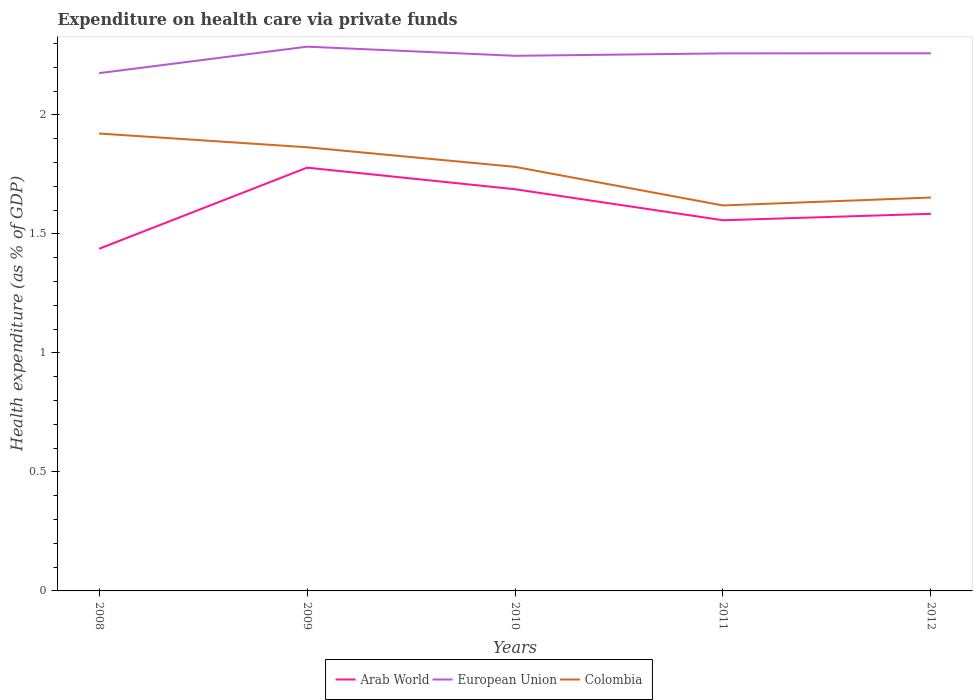Is the number of lines equal to the number of legend labels?
Offer a very short reply. Yes. Across all years, what is the maximum expenditure made on health care in Colombia?
Ensure brevity in your answer.  1.62. In which year was the expenditure made on health care in Arab World maximum?
Give a very brief answer. 2008. What is the total expenditure made on health care in European Union in the graph?
Provide a succinct answer. -0.08. What is the difference between the highest and the second highest expenditure made on health care in Arab World?
Offer a terse response. 0.34. Is the expenditure made on health care in European Union strictly greater than the expenditure made on health care in Colombia over the years?
Provide a short and direct response. No. How many lines are there?
Your answer should be very brief. 3. Does the graph contain grids?
Your response must be concise. No. How many legend labels are there?
Your answer should be very brief. 3. How are the legend labels stacked?
Offer a very short reply. Horizontal. What is the title of the graph?
Make the answer very short. Expenditure on health care via private funds. Does "Malaysia" appear as one of the legend labels in the graph?
Your answer should be compact. No. What is the label or title of the Y-axis?
Your response must be concise. Health expenditure (as % of GDP). What is the Health expenditure (as % of GDP) in Arab World in 2008?
Provide a short and direct response. 1.44. What is the Health expenditure (as % of GDP) in European Union in 2008?
Offer a very short reply. 2.18. What is the Health expenditure (as % of GDP) in Colombia in 2008?
Offer a very short reply. 1.92. What is the Health expenditure (as % of GDP) in Arab World in 2009?
Your answer should be compact. 1.78. What is the Health expenditure (as % of GDP) in European Union in 2009?
Provide a short and direct response. 2.29. What is the Health expenditure (as % of GDP) of Colombia in 2009?
Your answer should be compact. 1.86. What is the Health expenditure (as % of GDP) in Arab World in 2010?
Keep it short and to the point. 1.69. What is the Health expenditure (as % of GDP) of European Union in 2010?
Offer a very short reply. 2.25. What is the Health expenditure (as % of GDP) of Colombia in 2010?
Make the answer very short. 1.78. What is the Health expenditure (as % of GDP) of Arab World in 2011?
Give a very brief answer. 1.56. What is the Health expenditure (as % of GDP) of European Union in 2011?
Your answer should be compact. 2.26. What is the Health expenditure (as % of GDP) in Colombia in 2011?
Make the answer very short. 1.62. What is the Health expenditure (as % of GDP) in Arab World in 2012?
Your answer should be very brief. 1.58. What is the Health expenditure (as % of GDP) of European Union in 2012?
Your answer should be very brief. 2.26. What is the Health expenditure (as % of GDP) of Colombia in 2012?
Offer a terse response. 1.65. Across all years, what is the maximum Health expenditure (as % of GDP) of Arab World?
Your answer should be very brief. 1.78. Across all years, what is the maximum Health expenditure (as % of GDP) in European Union?
Make the answer very short. 2.29. Across all years, what is the maximum Health expenditure (as % of GDP) in Colombia?
Offer a very short reply. 1.92. Across all years, what is the minimum Health expenditure (as % of GDP) of Arab World?
Give a very brief answer. 1.44. Across all years, what is the minimum Health expenditure (as % of GDP) of European Union?
Keep it short and to the point. 2.18. Across all years, what is the minimum Health expenditure (as % of GDP) of Colombia?
Your answer should be compact. 1.62. What is the total Health expenditure (as % of GDP) in Arab World in the graph?
Provide a succinct answer. 8.05. What is the total Health expenditure (as % of GDP) of European Union in the graph?
Make the answer very short. 11.23. What is the total Health expenditure (as % of GDP) of Colombia in the graph?
Give a very brief answer. 8.84. What is the difference between the Health expenditure (as % of GDP) of Arab World in 2008 and that in 2009?
Your answer should be compact. -0.34. What is the difference between the Health expenditure (as % of GDP) in European Union in 2008 and that in 2009?
Offer a terse response. -0.11. What is the difference between the Health expenditure (as % of GDP) in Colombia in 2008 and that in 2009?
Your answer should be very brief. 0.06. What is the difference between the Health expenditure (as % of GDP) in Arab World in 2008 and that in 2010?
Your answer should be very brief. -0.25. What is the difference between the Health expenditure (as % of GDP) in European Union in 2008 and that in 2010?
Provide a succinct answer. -0.07. What is the difference between the Health expenditure (as % of GDP) in Colombia in 2008 and that in 2010?
Make the answer very short. 0.14. What is the difference between the Health expenditure (as % of GDP) of Arab World in 2008 and that in 2011?
Ensure brevity in your answer.  -0.12. What is the difference between the Health expenditure (as % of GDP) of European Union in 2008 and that in 2011?
Offer a very short reply. -0.08. What is the difference between the Health expenditure (as % of GDP) of Colombia in 2008 and that in 2011?
Keep it short and to the point. 0.3. What is the difference between the Health expenditure (as % of GDP) of Arab World in 2008 and that in 2012?
Ensure brevity in your answer.  -0.15. What is the difference between the Health expenditure (as % of GDP) of European Union in 2008 and that in 2012?
Your response must be concise. -0.08. What is the difference between the Health expenditure (as % of GDP) of Colombia in 2008 and that in 2012?
Your answer should be very brief. 0.27. What is the difference between the Health expenditure (as % of GDP) in Arab World in 2009 and that in 2010?
Keep it short and to the point. 0.09. What is the difference between the Health expenditure (as % of GDP) of European Union in 2009 and that in 2010?
Provide a short and direct response. 0.04. What is the difference between the Health expenditure (as % of GDP) of Colombia in 2009 and that in 2010?
Offer a very short reply. 0.08. What is the difference between the Health expenditure (as % of GDP) in Arab World in 2009 and that in 2011?
Your answer should be very brief. 0.22. What is the difference between the Health expenditure (as % of GDP) in European Union in 2009 and that in 2011?
Give a very brief answer. 0.03. What is the difference between the Health expenditure (as % of GDP) in Colombia in 2009 and that in 2011?
Your response must be concise. 0.24. What is the difference between the Health expenditure (as % of GDP) of Arab World in 2009 and that in 2012?
Ensure brevity in your answer.  0.19. What is the difference between the Health expenditure (as % of GDP) in European Union in 2009 and that in 2012?
Provide a succinct answer. 0.03. What is the difference between the Health expenditure (as % of GDP) in Colombia in 2009 and that in 2012?
Provide a succinct answer. 0.21. What is the difference between the Health expenditure (as % of GDP) in Arab World in 2010 and that in 2011?
Ensure brevity in your answer.  0.13. What is the difference between the Health expenditure (as % of GDP) of European Union in 2010 and that in 2011?
Give a very brief answer. -0.01. What is the difference between the Health expenditure (as % of GDP) in Colombia in 2010 and that in 2011?
Your answer should be compact. 0.16. What is the difference between the Health expenditure (as % of GDP) in Arab World in 2010 and that in 2012?
Your answer should be very brief. 0.1. What is the difference between the Health expenditure (as % of GDP) of European Union in 2010 and that in 2012?
Your answer should be compact. -0.01. What is the difference between the Health expenditure (as % of GDP) of Colombia in 2010 and that in 2012?
Your answer should be very brief. 0.13. What is the difference between the Health expenditure (as % of GDP) of Arab World in 2011 and that in 2012?
Give a very brief answer. -0.03. What is the difference between the Health expenditure (as % of GDP) in European Union in 2011 and that in 2012?
Provide a short and direct response. -0. What is the difference between the Health expenditure (as % of GDP) in Colombia in 2011 and that in 2012?
Provide a succinct answer. -0.03. What is the difference between the Health expenditure (as % of GDP) of Arab World in 2008 and the Health expenditure (as % of GDP) of European Union in 2009?
Provide a succinct answer. -0.85. What is the difference between the Health expenditure (as % of GDP) of Arab World in 2008 and the Health expenditure (as % of GDP) of Colombia in 2009?
Make the answer very short. -0.43. What is the difference between the Health expenditure (as % of GDP) in European Union in 2008 and the Health expenditure (as % of GDP) in Colombia in 2009?
Provide a succinct answer. 0.31. What is the difference between the Health expenditure (as % of GDP) in Arab World in 2008 and the Health expenditure (as % of GDP) in European Union in 2010?
Make the answer very short. -0.81. What is the difference between the Health expenditure (as % of GDP) of Arab World in 2008 and the Health expenditure (as % of GDP) of Colombia in 2010?
Offer a very short reply. -0.34. What is the difference between the Health expenditure (as % of GDP) of European Union in 2008 and the Health expenditure (as % of GDP) of Colombia in 2010?
Your answer should be compact. 0.39. What is the difference between the Health expenditure (as % of GDP) in Arab World in 2008 and the Health expenditure (as % of GDP) in European Union in 2011?
Provide a succinct answer. -0.82. What is the difference between the Health expenditure (as % of GDP) in Arab World in 2008 and the Health expenditure (as % of GDP) in Colombia in 2011?
Your answer should be compact. -0.18. What is the difference between the Health expenditure (as % of GDP) in European Union in 2008 and the Health expenditure (as % of GDP) in Colombia in 2011?
Your response must be concise. 0.56. What is the difference between the Health expenditure (as % of GDP) of Arab World in 2008 and the Health expenditure (as % of GDP) of European Union in 2012?
Your answer should be very brief. -0.82. What is the difference between the Health expenditure (as % of GDP) of Arab World in 2008 and the Health expenditure (as % of GDP) of Colombia in 2012?
Provide a succinct answer. -0.22. What is the difference between the Health expenditure (as % of GDP) of European Union in 2008 and the Health expenditure (as % of GDP) of Colombia in 2012?
Make the answer very short. 0.52. What is the difference between the Health expenditure (as % of GDP) in Arab World in 2009 and the Health expenditure (as % of GDP) in European Union in 2010?
Make the answer very short. -0.47. What is the difference between the Health expenditure (as % of GDP) in Arab World in 2009 and the Health expenditure (as % of GDP) in Colombia in 2010?
Provide a succinct answer. -0. What is the difference between the Health expenditure (as % of GDP) in European Union in 2009 and the Health expenditure (as % of GDP) in Colombia in 2010?
Your response must be concise. 0.5. What is the difference between the Health expenditure (as % of GDP) in Arab World in 2009 and the Health expenditure (as % of GDP) in European Union in 2011?
Make the answer very short. -0.48. What is the difference between the Health expenditure (as % of GDP) in Arab World in 2009 and the Health expenditure (as % of GDP) in Colombia in 2011?
Give a very brief answer. 0.16. What is the difference between the Health expenditure (as % of GDP) in European Union in 2009 and the Health expenditure (as % of GDP) in Colombia in 2011?
Offer a very short reply. 0.67. What is the difference between the Health expenditure (as % of GDP) of Arab World in 2009 and the Health expenditure (as % of GDP) of European Union in 2012?
Provide a succinct answer. -0.48. What is the difference between the Health expenditure (as % of GDP) in Arab World in 2009 and the Health expenditure (as % of GDP) in Colombia in 2012?
Your response must be concise. 0.13. What is the difference between the Health expenditure (as % of GDP) in European Union in 2009 and the Health expenditure (as % of GDP) in Colombia in 2012?
Keep it short and to the point. 0.63. What is the difference between the Health expenditure (as % of GDP) in Arab World in 2010 and the Health expenditure (as % of GDP) in European Union in 2011?
Keep it short and to the point. -0.57. What is the difference between the Health expenditure (as % of GDP) in Arab World in 2010 and the Health expenditure (as % of GDP) in Colombia in 2011?
Make the answer very short. 0.07. What is the difference between the Health expenditure (as % of GDP) of European Union in 2010 and the Health expenditure (as % of GDP) of Colombia in 2011?
Your answer should be very brief. 0.63. What is the difference between the Health expenditure (as % of GDP) in Arab World in 2010 and the Health expenditure (as % of GDP) in European Union in 2012?
Your response must be concise. -0.57. What is the difference between the Health expenditure (as % of GDP) of Arab World in 2010 and the Health expenditure (as % of GDP) of Colombia in 2012?
Your answer should be compact. 0.03. What is the difference between the Health expenditure (as % of GDP) of European Union in 2010 and the Health expenditure (as % of GDP) of Colombia in 2012?
Make the answer very short. 0.6. What is the difference between the Health expenditure (as % of GDP) in Arab World in 2011 and the Health expenditure (as % of GDP) in European Union in 2012?
Your answer should be compact. -0.7. What is the difference between the Health expenditure (as % of GDP) of Arab World in 2011 and the Health expenditure (as % of GDP) of Colombia in 2012?
Your answer should be compact. -0.1. What is the difference between the Health expenditure (as % of GDP) of European Union in 2011 and the Health expenditure (as % of GDP) of Colombia in 2012?
Your response must be concise. 0.61. What is the average Health expenditure (as % of GDP) of Arab World per year?
Provide a succinct answer. 1.61. What is the average Health expenditure (as % of GDP) of European Union per year?
Your answer should be very brief. 2.25. What is the average Health expenditure (as % of GDP) in Colombia per year?
Give a very brief answer. 1.77. In the year 2008, what is the difference between the Health expenditure (as % of GDP) in Arab World and Health expenditure (as % of GDP) in European Union?
Provide a short and direct response. -0.74. In the year 2008, what is the difference between the Health expenditure (as % of GDP) of Arab World and Health expenditure (as % of GDP) of Colombia?
Your response must be concise. -0.48. In the year 2008, what is the difference between the Health expenditure (as % of GDP) of European Union and Health expenditure (as % of GDP) of Colombia?
Your answer should be compact. 0.25. In the year 2009, what is the difference between the Health expenditure (as % of GDP) of Arab World and Health expenditure (as % of GDP) of European Union?
Make the answer very short. -0.51. In the year 2009, what is the difference between the Health expenditure (as % of GDP) in Arab World and Health expenditure (as % of GDP) in Colombia?
Offer a terse response. -0.09. In the year 2009, what is the difference between the Health expenditure (as % of GDP) of European Union and Health expenditure (as % of GDP) of Colombia?
Offer a very short reply. 0.42. In the year 2010, what is the difference between the Health expenditure (as % of GDP) of Arab World and Health expenditure (as % of GDP) of European Union?
Your answer should be very brief. -0.56. In the year 2010, what is the difference between the Health expenditure (as % of GDP) of Arab World and Health expenditure (as % of GDP) of Colombia?
Offer a very short reply. -0.09. In the year 2010, what is the difference between the Health expenditure (as % of GDP) in European Union and Health expenditure (as % of GDP) in Colombia?
Offer a very short reply. 0.47. In the year 2011, what is the difference between the Health expenditure (as % of GDP) of Arab World and Health expenditure (as % of GDP) of European Union?
Your answer should be compact. -0.7. In the year 2011, what is the difference between the Health expenditure (as % of GDP) of Arab World and Health expenditure (as % of GDP) of Colombia?
Offer a very short reply. -0.06. In the year 2011, what is the difference between the Health expenditure (as % of GDP) of European Union and Health expenditure (as % of GDP) of Colombia?
Your answer should be compact. 0.64. In the year 2012, what is the difference between the Health expenditure (as % of GDP) in Arab World and Health expenditure (as % of GDP) in European Union?
Your response must be concise. -0.67. In the year 2012, what is the difference between the Health expenditure (as % of GDP) of Arab World and Health expenditure (as % of GDP) of Colombia?
Your response must be concise. -0.07. In the year 2012, what is the difference between the Health expenditure (as % of GDP) of European Union and Health expenditure (as % of GDP) of Colombia?
Keep it short and to the point. 0.61. What is the ratio of the Health expenditure (as % of GDP) in Arab World in 2008 to that in 2009?
Keep it short and to the point. 0.81. What is the ratio of the Health expenditure (as % of GDP) in European Union in 2008 to that in 2009?
Provide a short and direct response. 0.95. What is the ratio of the Health expenditure (as % of GDP) in Colombia in 2008 to that in 2009?
Provide a short and direct response. 1.03. What is the ratio of the Health expenditure (as % of GDP) of Arab World in 2008 to that in 2010?
Provide a succinct answer. 0.85. What is the ratio of the Health expenditure (as % of GDP) in European Union in 2008 to that in 2010?
Your answer should be very brief. 0.97. What is the ratio of the Health expenditure (as % of GDP) of Colombia in 2008 to that in 2010?
Keep it short and to the point. 1.08. What is the ratio of the Health expenditure (as % of GDP) in Arab World in 2008 to that in 2011?
Offer a very short reply. 0.92. What is the ratio of the Health expenditure (as % of GDP) of European Union in 2008 to that in 2011?
Keep it short and to the point. 0.96. What is the ratio of the Health expenditure (as % of GDP) of Colombia in 2008 to that in 2011?
Ensure brevity in your answer.  1.19. What is the ratio of the Health expenditure (as % of GDP) in Arab World in 2008 to that in 2012?
Make the answer very short. 0.91. What is the ratio of the Health expenditure (as % of GDP) of European Union in 2008 to that in 2012?
Your answer should be very brief. 0.96. What is the ratio of the Health expenditure (as % of GDP) of Colombia in 2008 to that in 2012?
Offer a very short reply. 1.16. What is the ratio of the Health expenditure (as % of GDP) in Arab World in 2009 to that in 2010?
Ensure brevity in your answer.  1.05. What is the ratio of the Health expenditure (as % of GDP) of European Union in 2009 to that in 2010?
Your answer should be very brief. 1.02. What is the ratio of the Health expenditure (as % of GDP) in Colombia in 2009 to that in 2010?
Provide a succinct answer. 1.05. What is the ratio of the Health expenditure (as % of GDP) in Arab World in 2009 to that in 2011?
Offer a terse response. 1.14. What is the ratio of the Health expenditure (as % of GDP) of European Union in 2009 to that in 2011?
Provide a succinct answer. 1.01. What is the ratio of the Health expenditure (as % of GDP) of Colombia in 2009 to that in 2011?
Your answer should be very brief. 1.15. What is the ratio of the Health expenditure (as % of GDP) of Arab World in 2009 to that in 2012?
Offer a terse response. 1.12. What is the ratio of the Health expenditure (as % of GDP) of European Union in 2009 to that in 2012?
Your answer should be compact. 1.01. What is the ratio of the Health expenditure (as % of GDP) in Colombia in 2009 to that in 2012?
Your response must be concise. 1.13. What is the ratio of the Health expenditure (as % of GDP) of Arab World in 2010 to that in 2011?
Keep it short and to the point. 1.08. What is the ratio of the Health expenditure (as % of GDP) in European Union in 2010 to that in 2011?
Offer a very short reply. 1. What is the ratio of the Health expenditure (as % of GDP) of Colombia in 2010 to that in 2011?
Your answer should be compact. 1.1. What is the ratio of the Health expenditure (as % of GDP) of Arab World in 2010 to that in 2012?
Ensure brevity in your answer.  1.07. What is the ratio of the Health expenditure (as % of GDP) in Colombia in 2010 to that in 2012?
Your answer should be compact. 1.08. What is the ratio of the Health expenditure (as % of GDP) of Arab World in 2011 to that in 2012?
Provide a short and direct response. 0.98. What is the ratio of the Health expenditure (as % of GDP) of Colombia in 2011 to that in 2012?
Ensure brevity in your answer.  0.98. What is the difference between the highest and the second highest Health expenditure (as % of GDP) in Arab World?
Make the answer very short. 0.09. What is the difference between the highest and the second highest Health expenditure (as % of GDP) of European Union?
Provide a short and direct response. 0.03. What is the difference between the highest and the second highest Health expenditure (as % of GDP) in Colombia?
Give a very brief answer. 0.06. What is the difference between the highest and the lowest Health expenditure (as % of GDP) in Arab World?
Offer a terse response. 0.34. What is the difference between the highest and the lowest Health expenditure (as % of GDP) of European Union?
Offer a terse response. 0.11. What is the difference between the highest and the lowest Health expenditure (as % of GDP) of Colombia?
Offer a terse response. 0.3. 